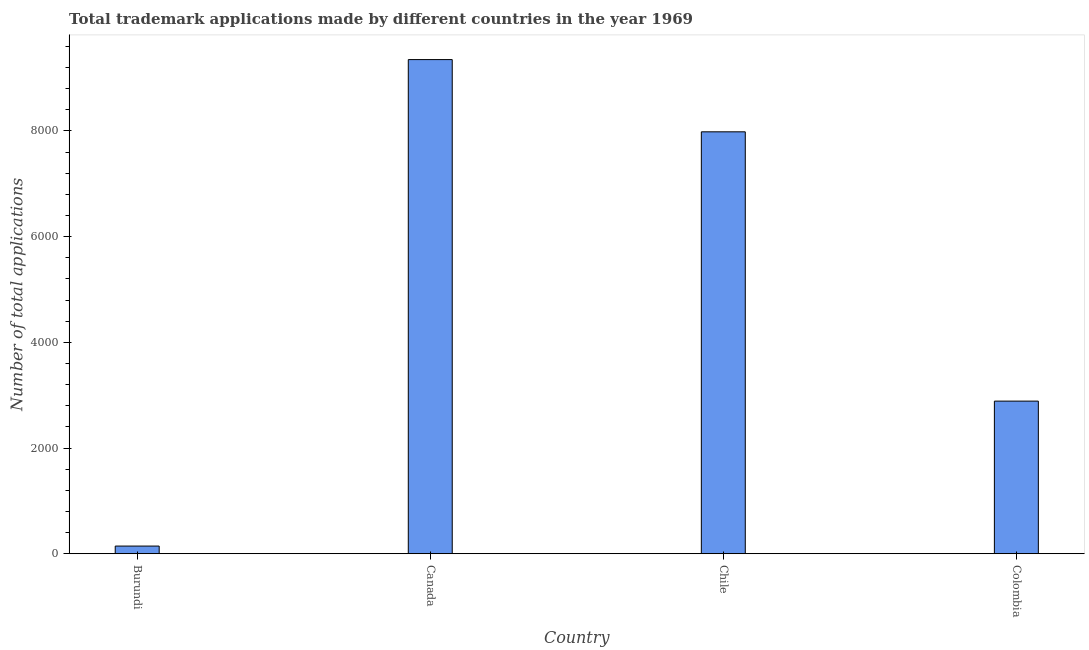Does the graph contain any zero values?
Give a very brief answer. No. Does the graph contain grids?
Provide a short and direct response. No. What is the title of the graph?
Your response must be concise. Total trademark applications made by different countries in the year 1969. What is the label or title of the X-axis?
Offer a terse response. Country. What is the label or title of the Y-axis?
Provide a short and direct response. Number of total applications. What is the number of trademark applications in Burundi?
Provide a succinct answer. 145. Across all countries, what is the maximum number of trademark applications?
Your answer should be compact. 9351. Across all countries, what is the minimum number of trademark applications?
Your response must be concise. 145. In which country was the number of trademark applications minimum?
Give a very brief answer. Burundi. What is the sum of the number of trademark applications?
Your response must be concise. 2.04e+04. What is the difference between the number of trademark applications in Canada and Chile?
Your response must be concise. 1367. What is the average number of trademark applications per country?
Your answer should be very brief. 5092. What is the median number of trademark applications?
Offer a very short reply. 5436. What is the ratio of the number of trademark applications in Burundi to that in Canada?
Offer a very short reply. 0.02. What is the difference between the highest and the second highest number of trademark applications?
Keep it short and to the point. 1367. What is the difference between the highest and the lowest number of trademark applications?
Offer a terse response. 9206. In how many countries, is the number of trademark applications greater than the average number of trademark applications taken over all countries?
Ensure brevity in your answer.  2. How many bars are there?
Keep it short and to the point. 4. Are the values on the major ticks of Y-axis written in scientific E-notation?
Your answer should be very brief. No. What is the Number of total applications in Burundi?
Make the answer very short. 145. What is the Number of total applications in Canada?
Keep it short and to the point. 9351. What is the Number of total applications in Chile?
Make the answer very short. 7984. What is the Number of total applications in Colombia?
Offer a very short reply. 2888. What is the difference between the Number of total applications in Burundi and Canada?
Offer a very short reply. -9206. What is the difference between the Number of total applications in Burundi and Chile?
Make the answer very short. -7839. What is the difference between the Number of total applications in Burundi and Colombia?
Ensure brevity in your answer.  -2743. What is the difference between the Number of total applications in Canada and Chile?
Offer a terse response. 1367. What is the difference between the Number of total applications in Canada and Colombia?
Make the answer very short. 6463. What is the difference between the Number of total applications in Chile and Colombia?
Give a very brief answer. 5096. What is the ratio of the Number of total applications in Burundi to that in Canada?
Offer a terse response. 0.02. What is the ratio of the Number of total applications in Burundi to that in Chile?
Offer a terse response. 0.02. What is the ratio of the Number of total applications in Burundi to that in Colombia?
Provide a succinct answer. 0.05. What is the ratio of the Number of total applications in Canada to that in Chile?
Offer a very short reply. 1.17. What is the ratio of the Number of total applications in Canada to that in Colombia?
Your response must be concise. 3.24. What is the ratio of the Number of total applications in Chile to that in Colombia?
Provide a succinct answer. 2.77. 